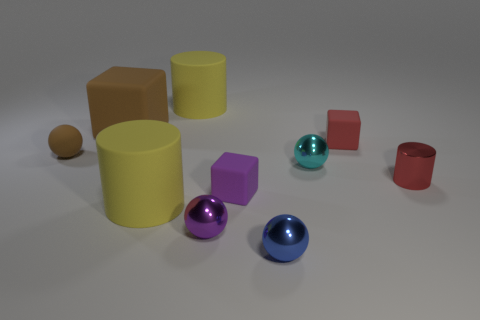Subtract all small cyan balls. How many balls are left? 3 Subtract 1 blocks. How many blocks are left? 2 Subtract all blue spheres. How many spheres are left? 3 Subtract all gray balls. Subtract all cyan cylinders. How many balls are left? 4 Subtract all cylinders. How many objects are left? 7 Add 1 large matte things. How many large matte things are left? 4 Add 8 big cylinders. How many big cylinders exist? 10 Subtract 0 yellow balls. How many objects are left? 10 Subtract all blue shiny cylinders. Subtract all cyan metallic things. How many objects are left? 9 